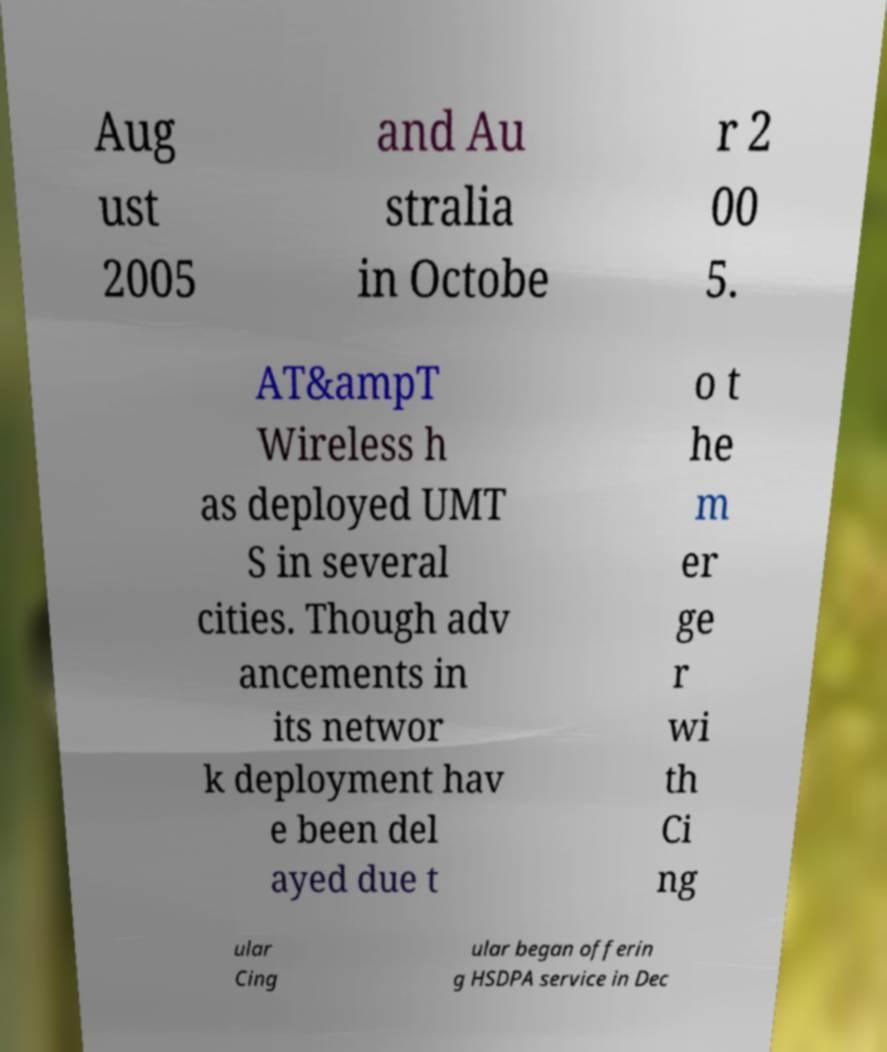Can you read and provide the text displayed in the image?This photo seems to have some interesting text. Can you extract and type it out for me? Aug ust 2005 and Au stralia in Octobe r 2 00 5. AT&ampT Wireless h as deployed UMT S in several cities. Though adv ancements in its networ k deployment hav e been del ayed due t o t he m er ge r wi th Ci ng ular Cing ular began offerin g HSDPA service in Dec 